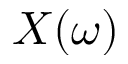<formula> <loc_0><loc_0><loc_500><loc_500>X ( \omega )</formula> 